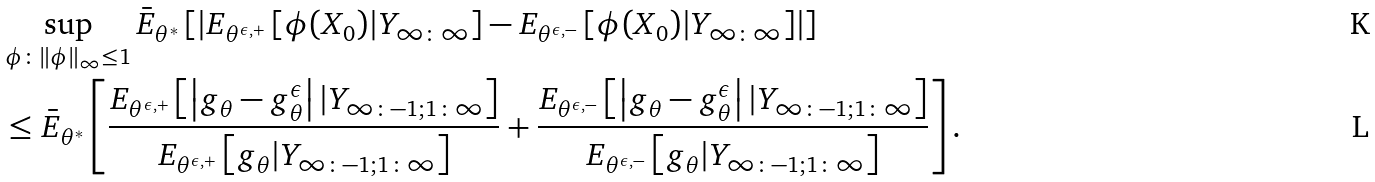Convert formula to latex. <formula><loc_0><loc_0><loc_500><loc_500>& \sup _ { \phi \colon \left \| \phi \right \| _ { \infty } \leq 1 } \bar { E } _ { \theta ^ { \ast } } \left [ \left | E _ { \theta ^ { \epsilon , + } } \left [ \phi ( X _ { 0 } ) | Y _ { \infty \colon \infty } \right ] - E _ { \theta ^ { \epsilon , - } } \left [ \phi ( X _ { 0 } ) | Y _ { \infty \colon \infty } \right ] \right | \right ] \\ & \leq \bar { E } _ { \theta ^ { \ast } } \left [ \frac { E _ { \theta ^ { \epsilon , + } } \left [ \left | g _ { \theta } - g _ { \theta } ^ { \epsilon } \right | | Y _ { \infty \colon - 1 ; 1 \colon \infty } \right ] } { E _ { \theta ^ { \epsilon , + } } \left [ g _ { \theta } | Y _ { \infty \colon - 1 ; 1 \colon \infty } \right ] } + \frac { E _ { \theta ^ { \epsilon , - } } \left [ \left | g _ { \theta } - g _ { \theta } ^ { \epsilon } \right | | Y _ { \infty \colon - 1 ; 1 \colon \infty } \right ] } { E _ { \theta ^ { \epsilon , - } } \left [ g _ { \theta } | Y _ { \infty \colon - 1 ; 1 \colon \infty } \right ] } \right ] .</formula> 